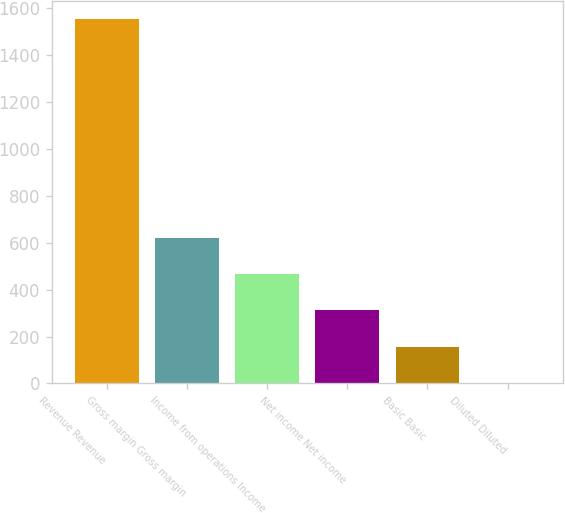Convert chart. <chart><loc_0><loc_0><loc_500><loc_500><bar_chart><fcel>Revenue Revenue<fcel>Gross margin Gross margin<fcel>Income from operations Income<fcel>Net income Net income<fcel>Basic Basic<fcel>Diluted Diluted<nl><fcel>1553<fcel>621.41<fcel>466.14<fcel>310.87<fcel>155.6<fcel>0.33<nl></chart> 